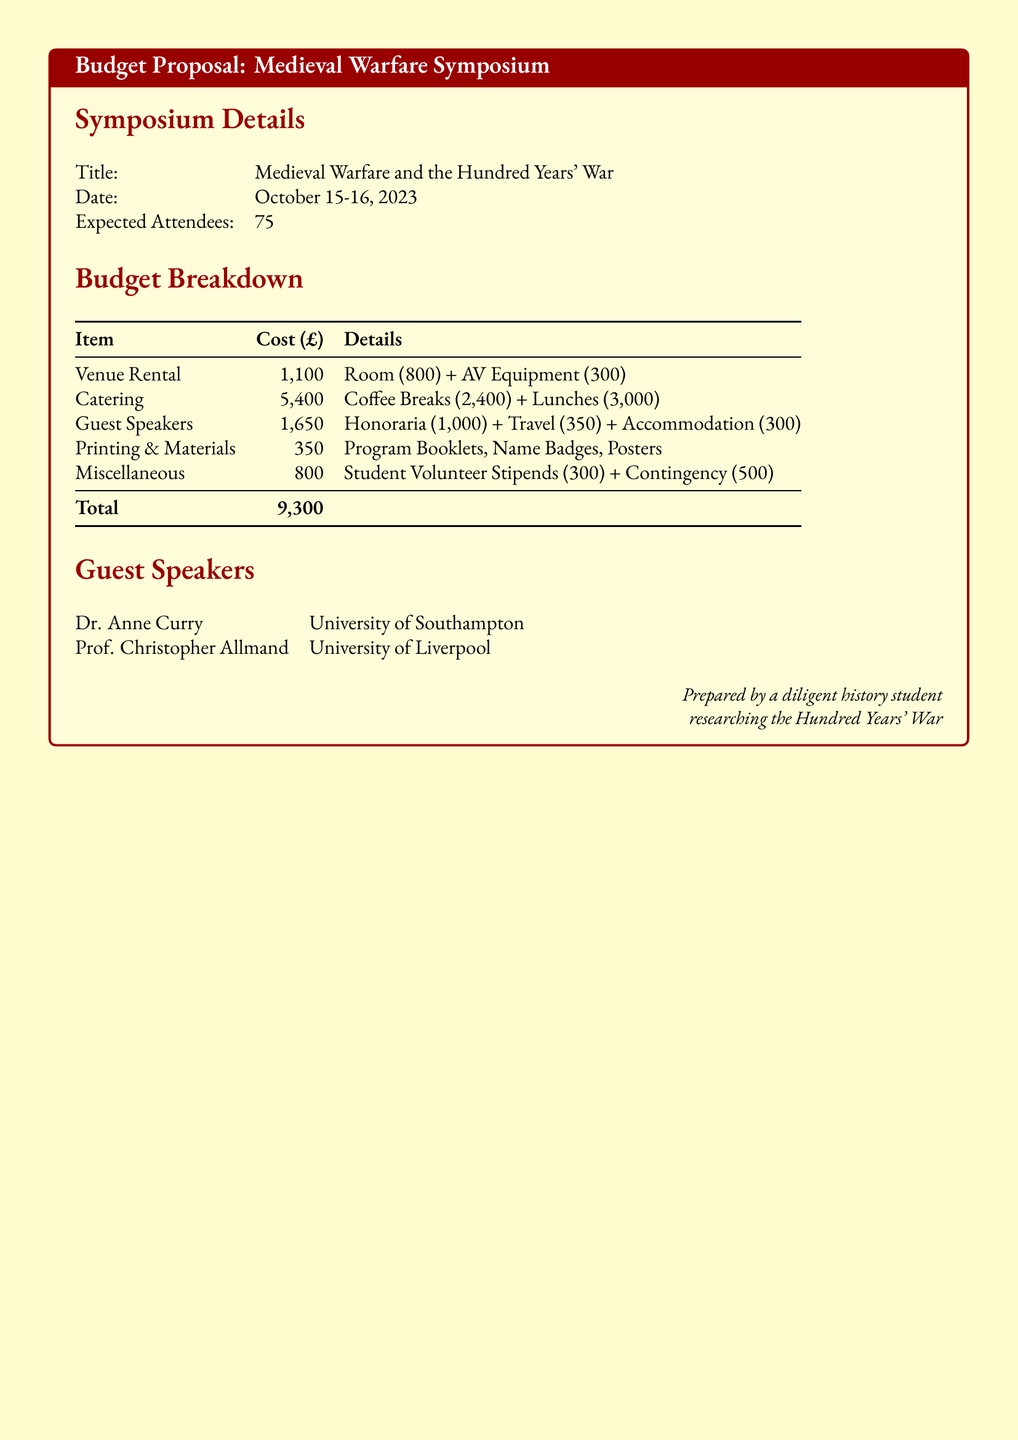What is the title of the symposium? The title is provided in the symposium details section of the document.
Answer: Medieval Warfare and the Hundred Years' War When is the symposium scheduled to take place? The date is listed in the symposium details section.
Answer: October 15-16, 2023 How many expected attendees are there? The expected number of attendees is specified in the document.
Answer: 75 What is the total budget for the symposium? The total is concluded from the budget breakdown table in the document.
Answer: 9,300 What is the cost of catering? The breakdown of costs lists catering expenses separately.
Answer: 5,400 Who is one of the guest speakers? The guest speaker names are provided in a dedicated section of the document.
Answer: Dr. Anne Curry What are the venue rental expenses? The venue rental costs are outlined in the budget breakdown.
Answer: 1,100 What is allocated for miscellaneous expenses? The miscellaneous section specifies its budget.
Answer: 800 How much is allocated for guest speaker travel? The travel cost for guest speakers is itemized in the document.
Answer: 350 What are the two components of catering costs? The catering expenses are divided into specific components in the budget.
Answer: Coffee Breaks and Lunches 